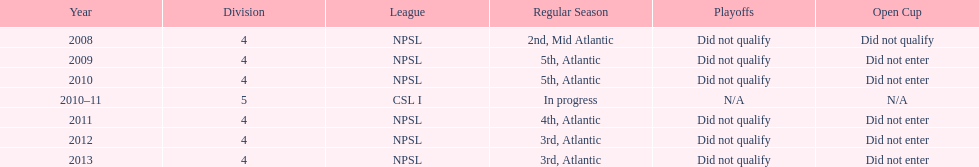What is the unique year that is referred to as n/a? 2010-11. Help me parse the entirety of this table. {'header': ['Year', 'Division', 'League', 'Regular Season', 'Playoffs', 'Open Cup'], 'rows': [['2008', '4', 'NPSL', '2nd, Mid Atlantic', 'Did not qualify', 'Did not qualify'], ['2009', '4', 'NPSL', '5th, Atlantic', 'Did not qualify', 'Did not enter'], ['2010', '4', 'NPSL', '5th, Atlantic', 'Did not qualify', 'Did not enter'], ['2010–11', '5', 'CSL I', 'In progress', 'N/A', 'N/A'], ['2011', '4', 'NPSL', '4th, Atlantic', 'Did not qualify', 'Did not enter'], ['2012', '4', 'NPSL', '3rd, Atlantic', 'Did not qualify', 'Did not enter'], ['2013', '4', 'NPSL', '3rd, Atlantic', 'Did not qualify', 'Did not enter']]} 